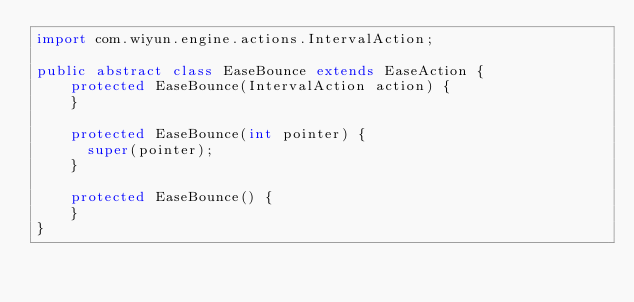Convert code to text. <code><loc_0><loc_0><loc_500><loc_500><_Java_>import com.wiyun.engine.actions.IntervalAction;

public abstract class EaseBounce extends EaseAction {
    protected EaseBounce(IntervalAction action) {
    }
    
    protected EaseBounce(int pointer) {
    	super(pointer);
    }
    
    protected EaseBounce() {
    }
}
</code> 